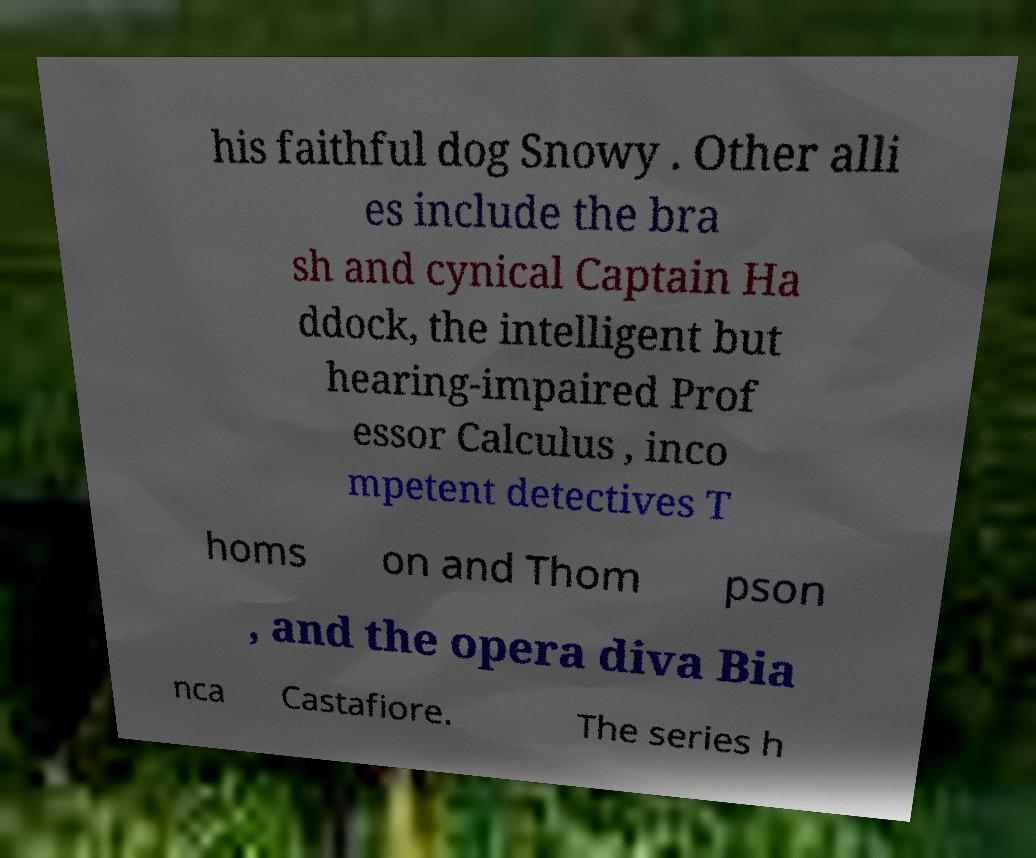What messages or text are displayed in this image? I need them in a readable, typed format. his faithful dog Snowy . Other alli es include the bra sh and cynical Captain Ha ddock, the intelligent but hearing-impaired Prof essor Calculus , inco mpetent detectives T homs on and Thom pson , and the opera diva Bia nca Castafiore. The series h 